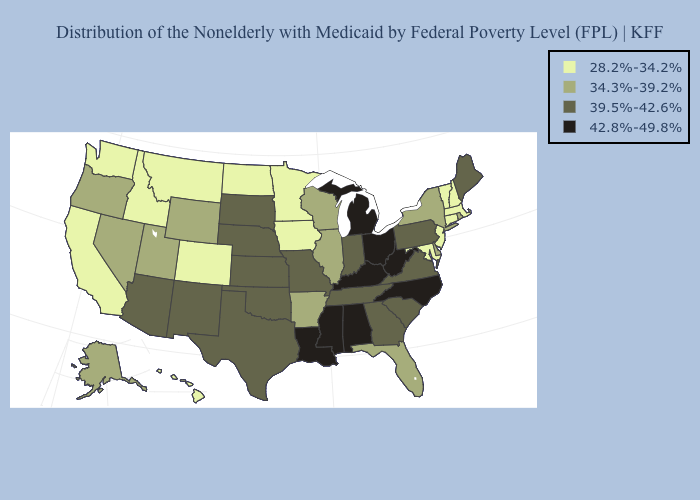Does Oklahoma have a lower value than Idaho?
Short answer required. No. Does New Mexico have the lowest value in the West?
Keep it brief. No. Name the states that have a value in the range 28.2%-34.2%?
Concise answer only. California, Colorado, Connecticut, Hawaii, Idaho, Iowa, Maryland, Massachusetts, Minnesota, Montana, New Hampshire, New Jersey, North Dakota, Vermont, Washington. Does the first symbol in the legend represent the smallest category?
Keep it brief. Yes. Does Maryland have the lowest value in the South?
Keep it brief. Yes. Does Kentucky have the highest value in the South?
Short answer required. Yes. What is the value of Montana?
Answer briefly. 28.2%-34.2%. Does the map have missing data?
Quick response, please. No. What is the value of Pennsylvania?
Quick response, please. 39.5%-42.6%. What is the value of Utah?
Quick response, please. 34.3%-39.2%. What is the highest value in the MidWest ?
Write a very short answer. 42.8%-49.8%. How many symbols are there in the legend?
Quick response, please. 4. Does Arkansas have the highest value in the USA?
Be succinct. No. Does the map have missing data?
Be succinct. No. Name the states that have a value in the range 34.3%-39.2%?
Short answer required. Alaska, Arkansas, Delaware, Florida, Illinois, Nevada, New York, Oregon, Rhode Island, Utah, Wisconsin, Wyoming. 